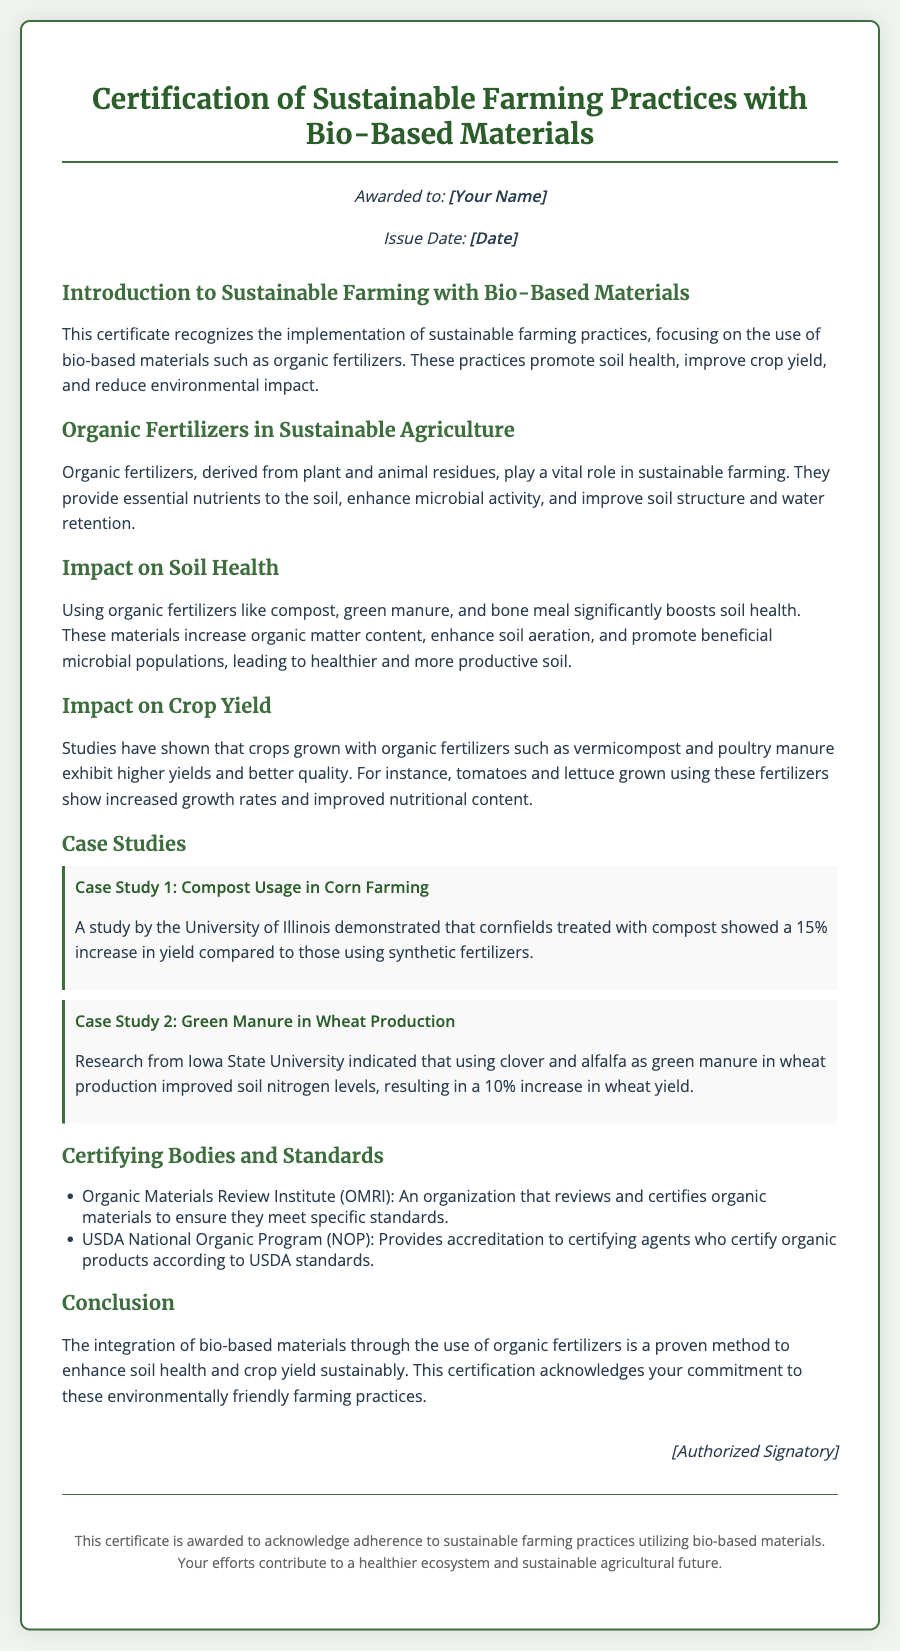what is the title of the certificate? The title is located at the top of the document, indicating the purpose of the certification.
Answer: Certification of Sustainable Farming Practices with Bio-Based Materials who is the issuing body for the certification? The document lists organizations responsible for certifying organic materials in the section about certifying bodies.
Answer: Organic Materials Review Institute (OMRI) what is one example of a crop mentioned that benefits from organic fertilizers? The document provides examples of crops discussed in relation to organic fertilizers in the section on crop yield.
Answer: tomatoes what percentage increase in yield was observed in cornfields treated with compost? The document contains a specific statistic from a study highlighting the impact of compost on corn yield.
Answer: 15% which case study discusses green manure in wheat production? The document features case studies, one of which specifically addresses green manure use in relation to wheat.
Answer: Case Study 2: Green Manure in Wheat Production what is one impact of organic fertilizers on soil health according to the document? The document outlines several benefits of using organic fertilizers, particularly on soil health.
Answer: enhances microbial activity how does the document conclude about the integration of bio-based materials? The conclusion summarizes the overall benefits and commitments in agricultural practices highlighted throughout the document.
Answer: enhances soil health and crop yield sustainably what is the role of the USDA National Organic Program? The document specifies the functions of different certifying bodies, including this program.
Answer: Provides accreditation to certifying agents 